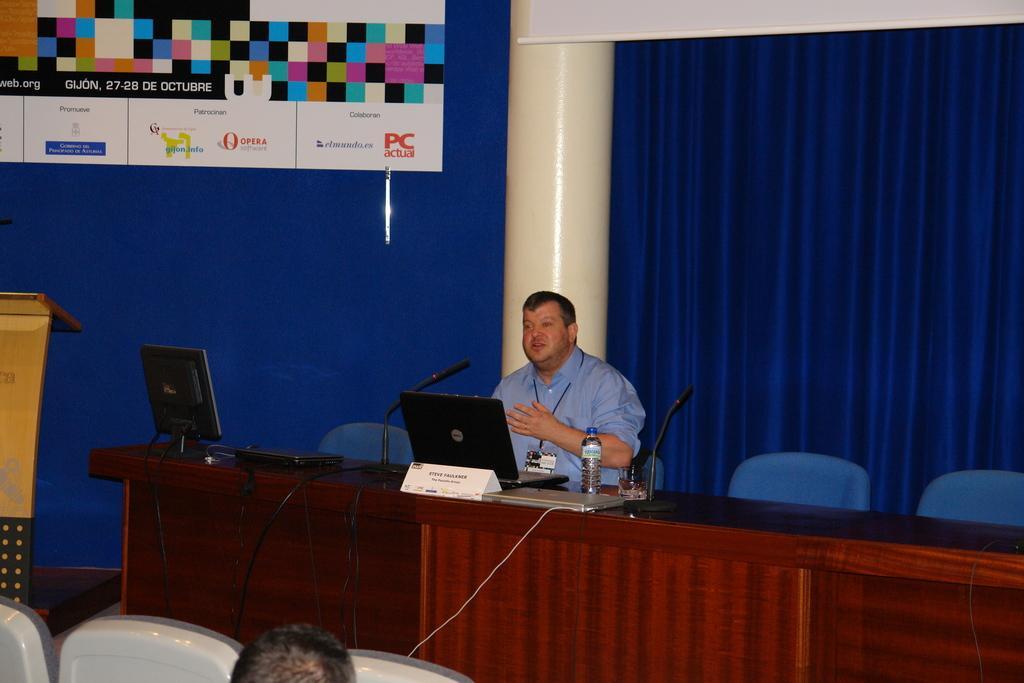In one or two sentences, can you explain what this image depicts? In this picture we can see a man sitting on a chair. In front of him we can see laptops, mics, bottle, monitor, glass, name board, table, cables and some objects. At the back of him we can see the wall, pillar, podium, curtains and banners. 